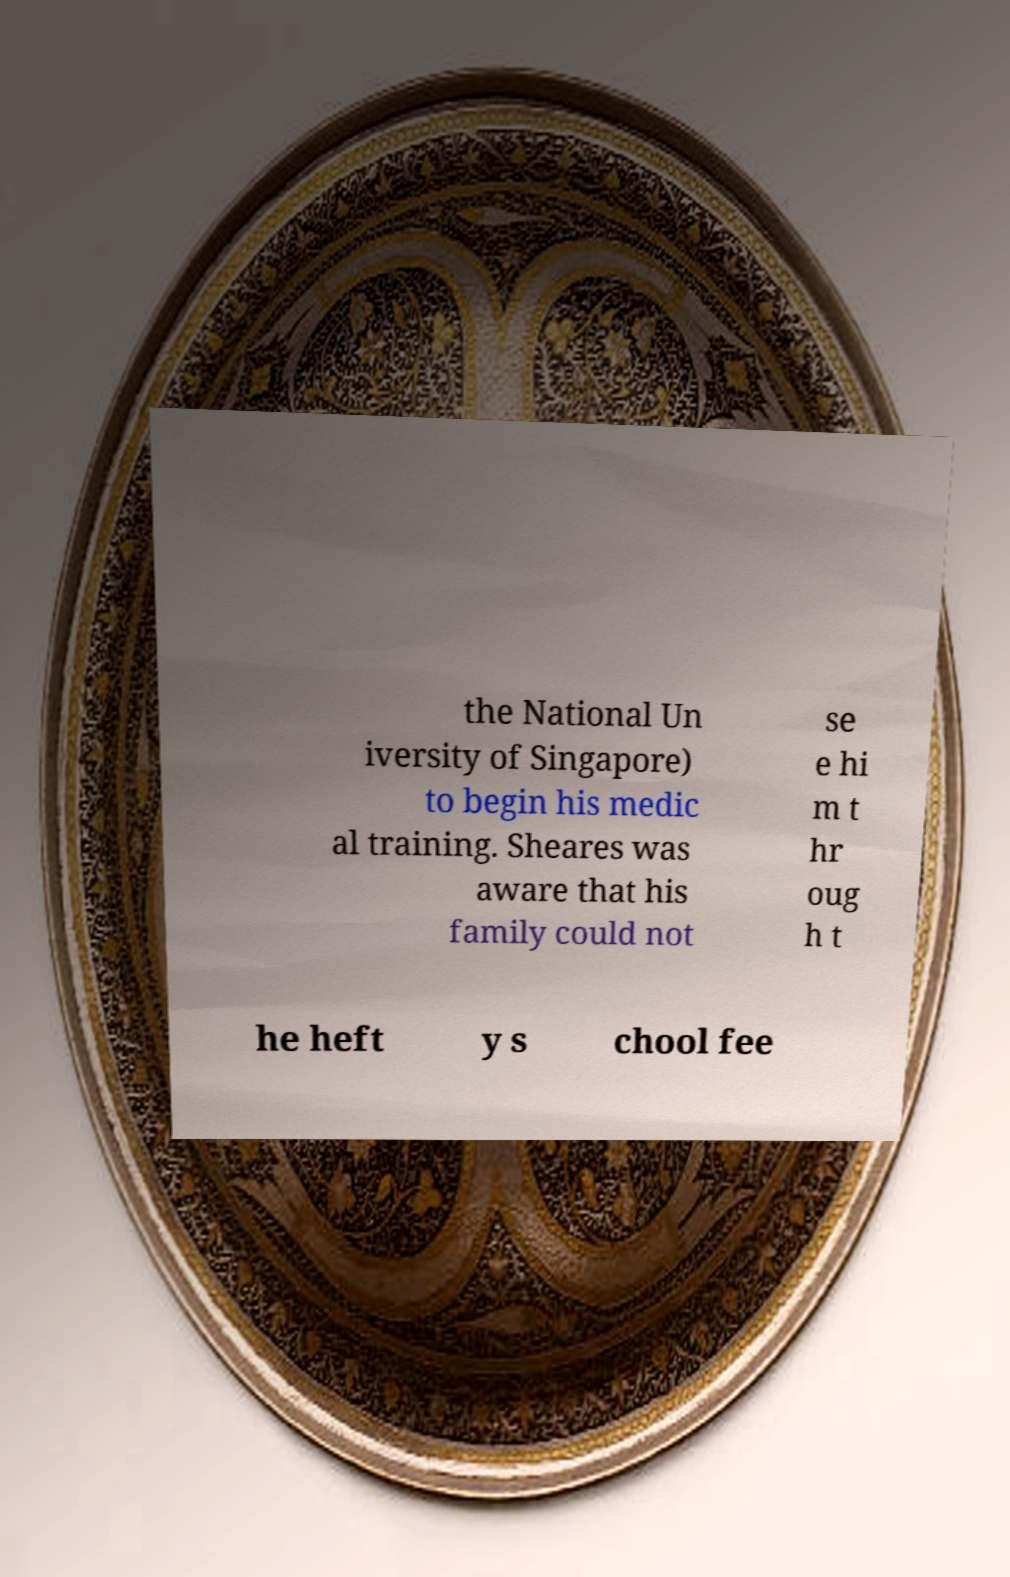Please identify and transcribe the text found in this image. the National Un iversity of Singapore) to begin his medic al training. Sheares was aware that his family could not se e hi m t hr oug h t he heft y s chool fee 